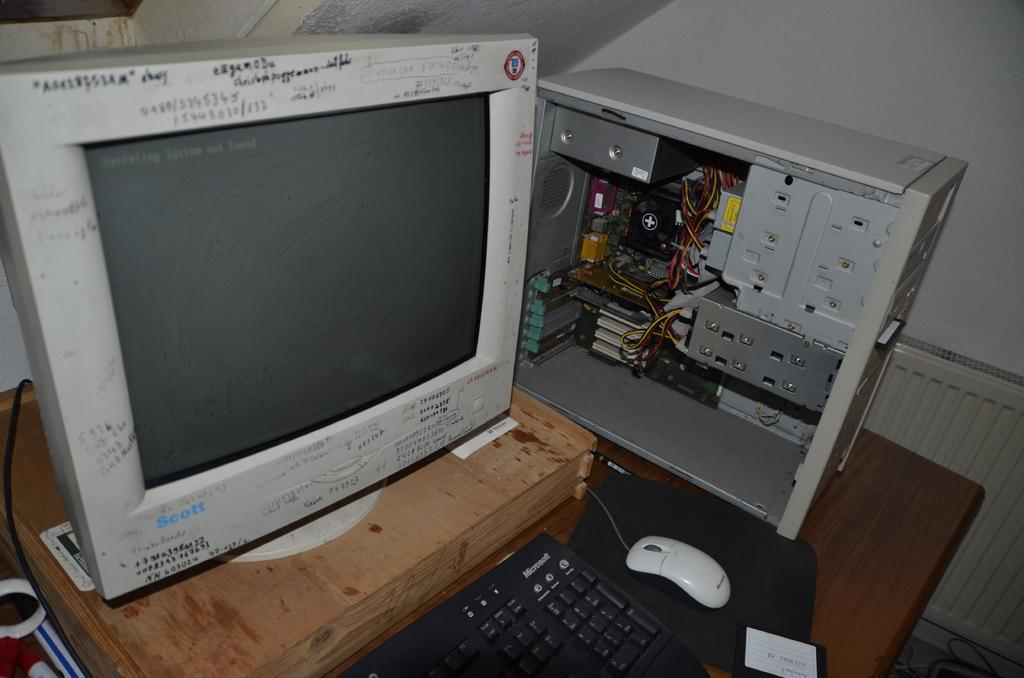Provide a one-sentence caption for the provided image. A computer sits on a table top, the mouse and keyboard are from Microsoft. 